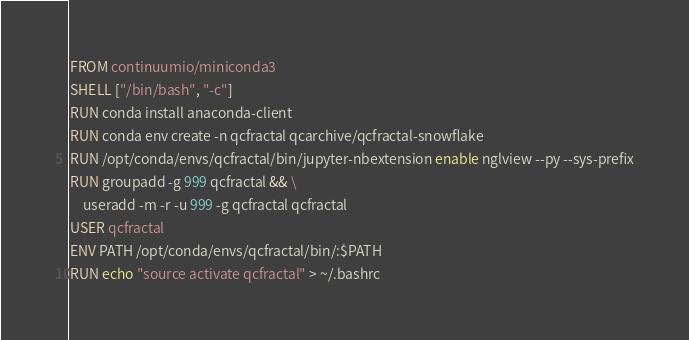<code> <loc_0><loc_0><loc_500><loc_500><_Dockerfile_>FROM continuumio/miniconda3
SHELL ["/bin/bash", "-c"]
RUN conda install anaconda-client
RUN conda env create -n qcfractal qcarchive/qcfractal-snowflake
RUN /opt/conda/envs/qcfractal/bin/jupyter-nbextension enable nglview --py --sys-prefix
RUN groupadd -g 999 qcfractal && \
    useradd -m -r -u 999 -g qcfractal qcfractal
USER qcfractal
ENV PATH /opt/conda/envs/qcfractal/bin/:$PATH
RUN echo "source activate qcfractal" > ~/.bashrc
</code> 